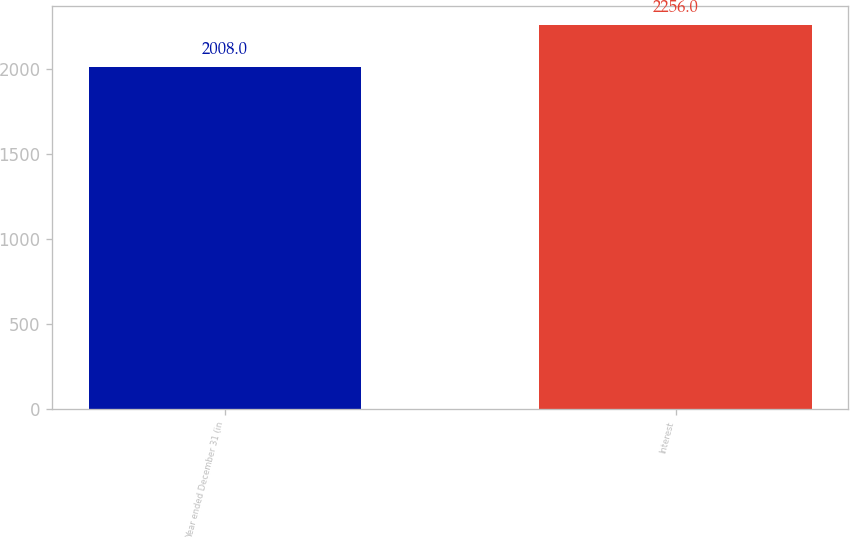<chart> <loc_0><loc_0><loc_500><loc_500><bar_chart><fcel>Year ended December 31 (in<fcel>Interest<nl><fcel>2008<fcel>2256<nl></chart> 